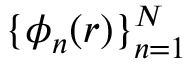Convert formula to latex. <formula><loc_0><loc_0><loc_500><loc_500>\{ \phi _ { n } ( r ) \} _ { n = 1 } ^ { N }</formula> 